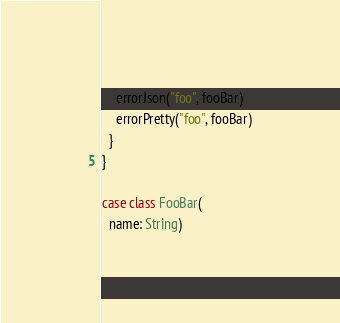Convert code to text. <code><loc_0><loc_0><loc_500><loc_500><_Scala_>
    errorJson("foo", fooBar)
    errorPretty("foo", fooBar)
  }
}

case class FooBar(
  name: String)</code> 